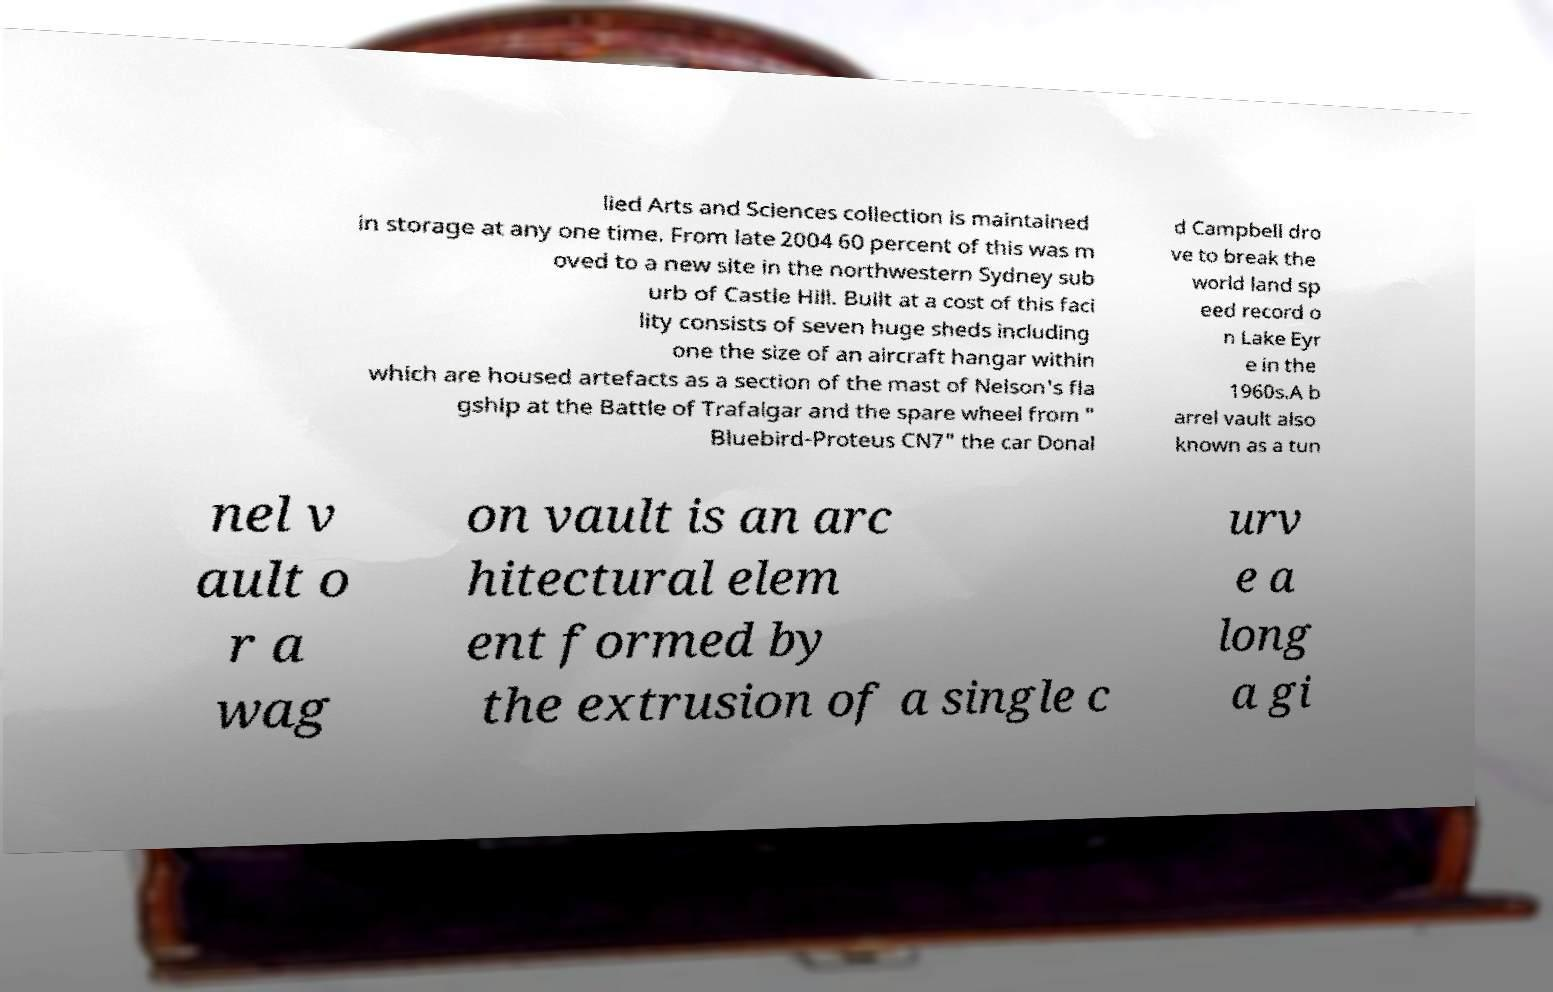There's text embedded in this image that I need extracted. Can you transcribe it verbatim? lied Arts and Sciences collection is maintained in storage at any one time. From late 2004 60 percent of this was m oved to a new site in the northwestern Sydney sub urb of Castle Hill. Built at a cost of this faci lity consists of seven huge sheds including one the size of an aircraft hangar within which are housed artefacts as a section of the mast of Nelson's fla gship at the Battle of Trafalgar and the spare wheel from " Bluebird-Proteus CN7" the car Donal d Campbell dro ve to break the world land sp eed record o n Lake Eyr e in the 1960s.A b arrel vault also known as a tun nel v ault o r a wag on vault is an arc hitectural elem ent formed by the extrusion of a single c urv e a long a gi 